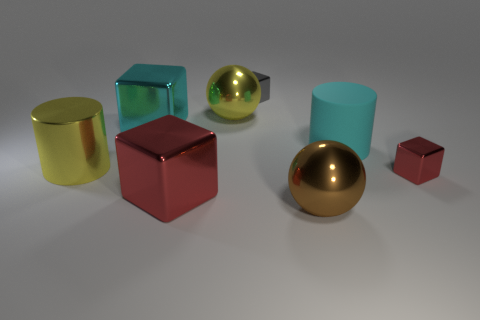Are there any other things that have the same material as the cyan cylinder?
Offer a terse response. No. Is the large yellow sphere made of the same material as the large brown thing?
Give a very brief answer. Yes. How many things are either large brown balls or small gray things?
Your answer should be very brief. 2. What is the size of the cyan cube?
Your answer should be very brief. Large. Are there fewer gray matte things than big cyan rubber cylinders?
Your answer should be compact. Yes. How many metallic balls are the same color as the metal cylinder?
Provide a short and direct response. 1. There is a metal ball behind the large brown thing; is it the same color as the large rubber cylinder?
Your answer should be very brief. No. What shape is the cyan object that is left of the gray thing?
Provide a short and direct response. Cube. There is a large shiny sphere behind the brown sphere; is there a yellow metal sphere to the left of it?
Your answer should be compact. No. How many large red things are the same material as the gray object?
Make the answer very short. 1. 